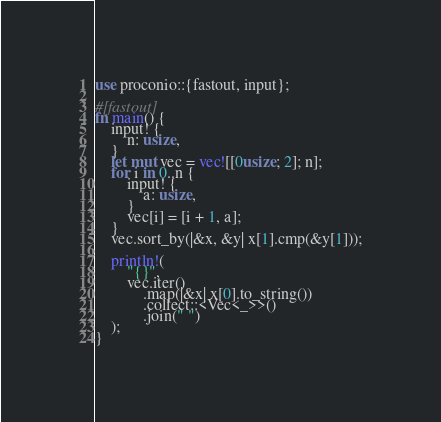Convert code to text. <code><loc_0><loc_0><loc_500><loc_500><_Rust_>use proconio::{fastout, input};

#[fastout]
fn main() {
    input! {
        n: usize,
    }
    let mut vec = vec![[0usize; 2]; n];
    for i in 0..n {
        input! {
            a: usize,
        }
        vec[i] = [i + 1, a];
    }
    vec.sort_by(|&x, &y| x[1].cmp(&y[1]));

    println!(
        "{}",
        vec.iter()
            .map(|&x| x[0].to_string())
            .collect::<Vec<_>>()
            .join(" ")
    );
}
</code> 